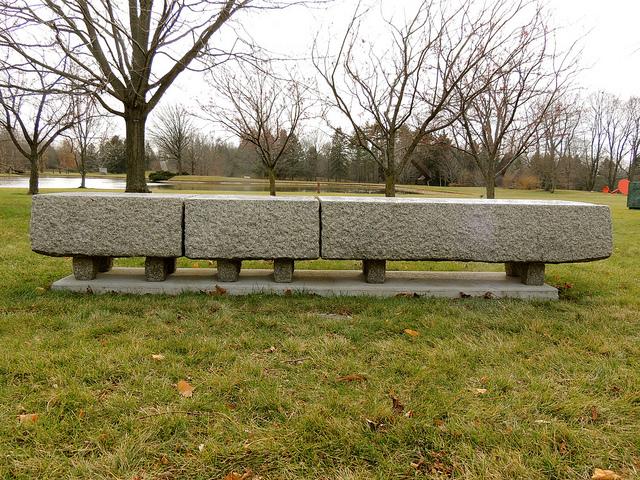What season is it?
Keep it brief. Fall. What material is the bench made of?
Answer briefly. Concrete. Is it springtime?
Short answer required. No. Would a person be in danger of large mammal attacks here?
Quick response, please. No. What is the bench made of?
Be succinct. Concrete. Is that a stone building?
Be succinct. No. Would you feel comfortable sitting on this stone bench?
Write a very short answer. No. 